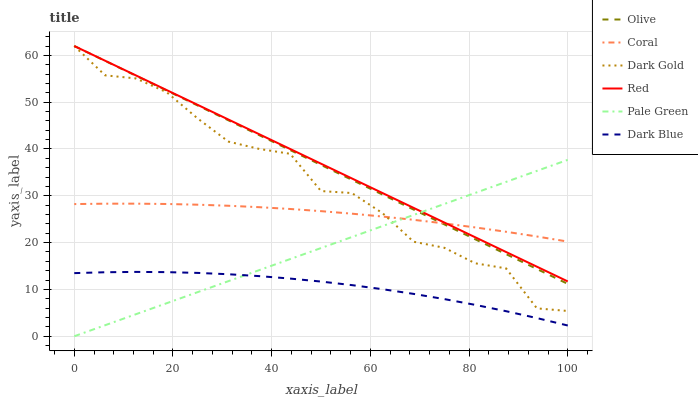Does Dark Blue have the minimum area under the curve?
Answer yes or no. Yes. Does Red have the maximum area under the curve?
Answer yes or no. Yes. Does Coral have the minimum area under the curve?
Answer yes or no. No. Does Coral have the maximum area under the curve?
Answer yes or no. No. Is Pale Green the smoothest?
Answer yes or no. Yes. Is Dark Gold the roughest?
Answer yes or no. Yes. Is Coral the smoothest?
Answer yes or no. No. Is Coral the roughest?
Answer yes or no. No. Does Pale Green have the lowest value?
Answer yes or no. Yes. Does Dark Blue have the lowest value?
Answer yes or no. No. Does Red have the highest value?
Answer yes or no. Yes. Does Coral have the highest value?
Answer yes or no. No. Is Dark Blue less than Dark Gold?
Answer yes or no. Yes. Is Dark Gold greater than Dark Blue?
Answer yes or no. Yes. Does Coral intersect Dark Gold?
Answer yes or no. Yes. Is Coral less than Dark Gold?
Answer yes or no. No. Is Coral greater than Dark Gold?
Answer yes or no. No. Does Dark Blue intersect Dark Gold?
Answer yes or no. No. 